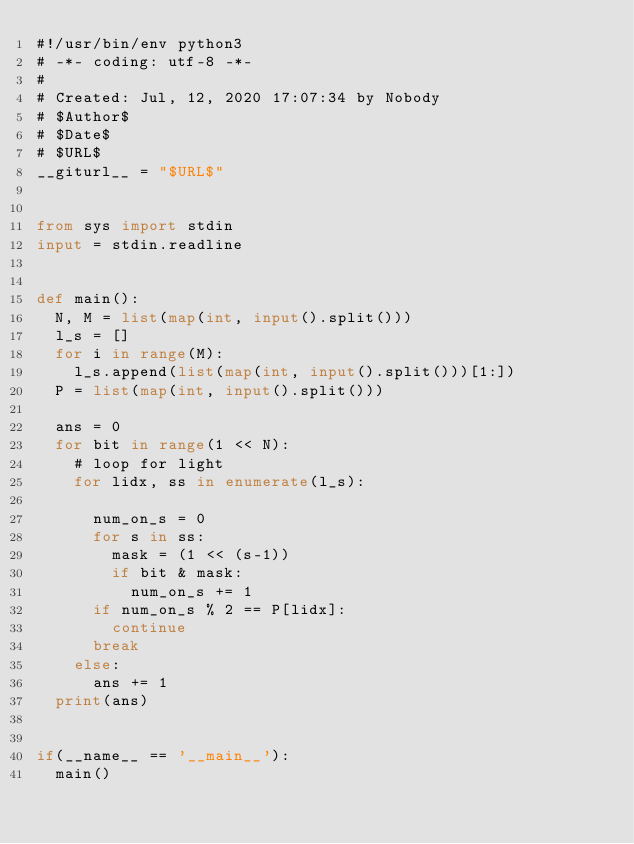<code> <loc_0><loc_0><loc_500><loc_500><_Python_>#!/usr/bin/env python3
# -*- coding: utf-8 -*-
#
# Created: Jul, 12, 2020 17:07:34 by Nobody
# $Author$
# $Date$
# $URL$
__giturl__ = "$URL$"


from sys import stdin
input = stdin.readline


def main():
  N, M = list(map(int, input().split()))
  l_s = []
  for i in range(M):
    l_s.append(list(map(int, input().split()))[1:])
  P = list(map(int, input().split()))

  ans = 0
  for bit in range(1 << N):
    # loop for light
    for lidx, ss in enumerate(l_s):

      num_on_s = 0
      for s in ss:
        mask = (1 << (s-1))
        if bit & mask:
          num_on_s += 1
      if num_on_s % 2 == P[lidx]:
        continue
      break
    else:
      ans += 1
  print(ans)


if(__name__ == '__main__'):
  main()
</code> 